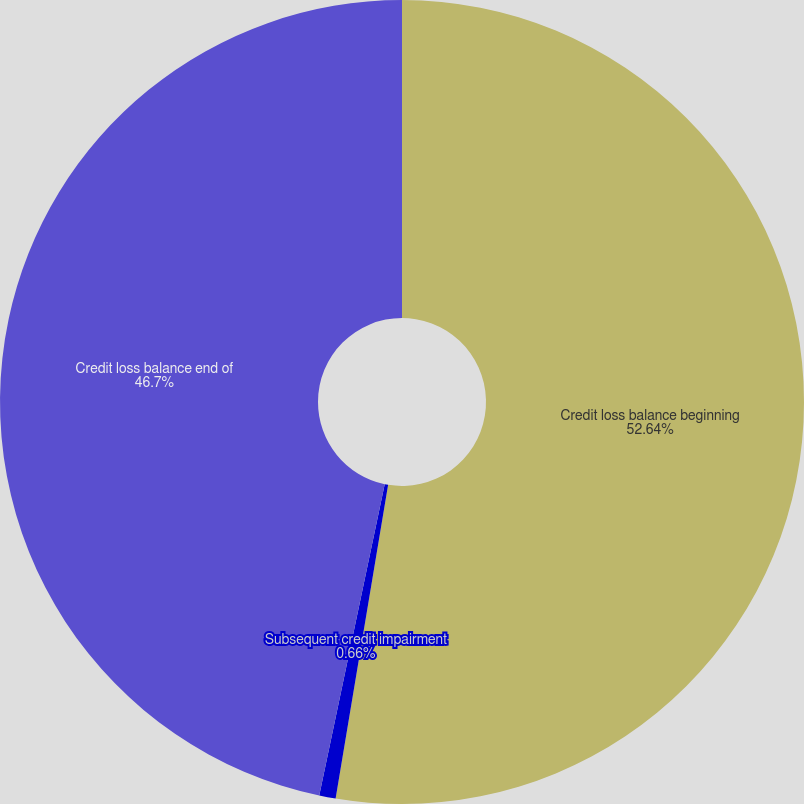<chart> <loc_0><loc_0><loc_500><loc_500><pie_chart><fcel>Credit loss balance beginning<fcel>Subsequent credit impairment<fcel>Credit loss balance end of<nl><fcel>52.64%<fcel>0.66%<fcel>46.7%<nl></chart> 